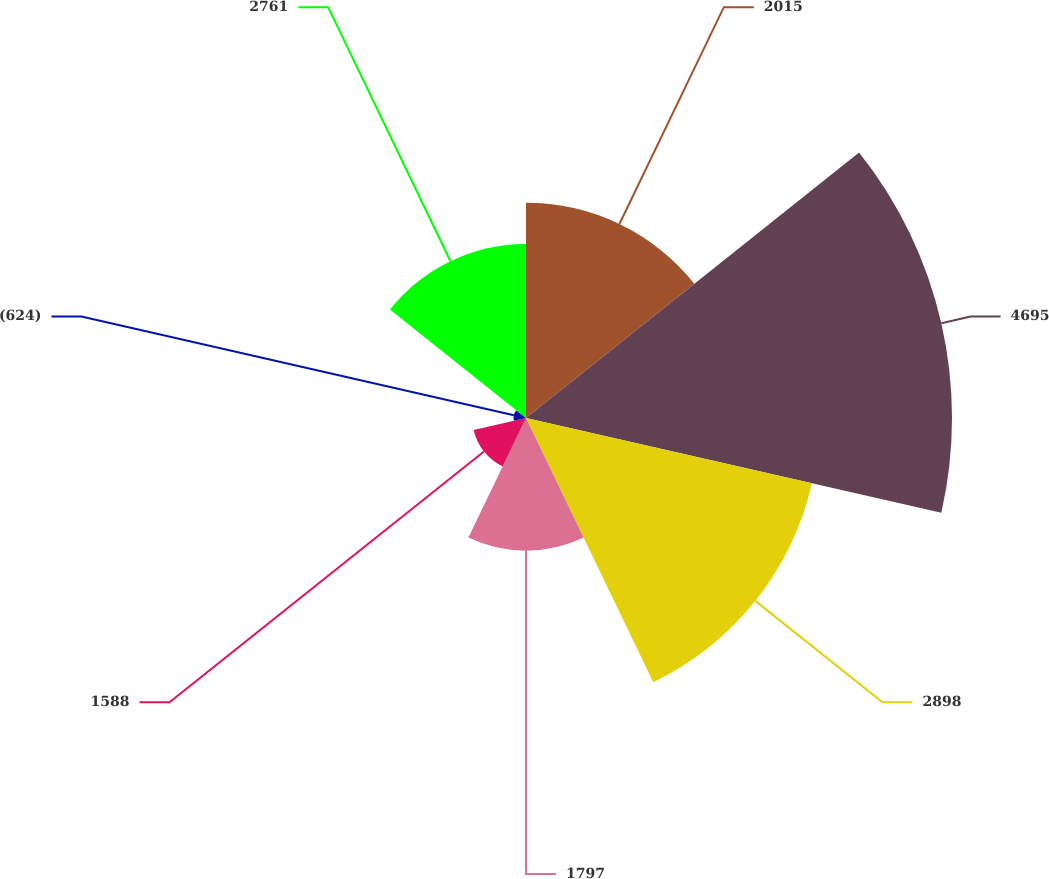Convert chart. <chart><loc_0><loc_0><loc_500><loc_500><pie_chart><fcel>2015<fcel>4695<fcel>2898<fcel>1797<fcel>1588<fcel>(624)<fcel>2761<nl><fcel>16.47%<fcel>32.58%<fcel>22.43%<fcel>10.15%<fcel>4.11%<fcel>0.95%<fcel>13.31%<nl></chart> 